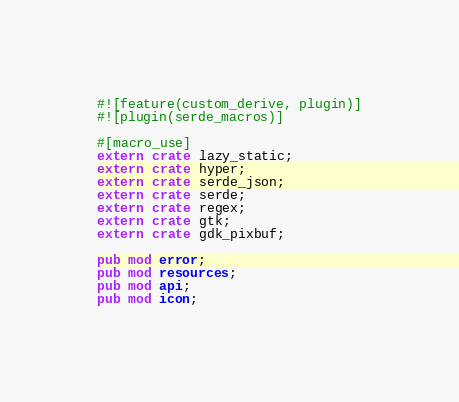<code> <loc_0><loc_0><loc_500><loc_500><_Rust_>#![feature(custom_derive, plugin)]
#![plugin(serde_macros)]

#[macro_use]
extern crate lazy_static;
extern crate hyper;
extern crate serde_json;
extern crate serde;
extern crate regex;
extern crate gtk;
extern crate gdk_pixbuf;

pub mod error;
pub mod resources;
pub mod api;
pub mod icon;
</code> 